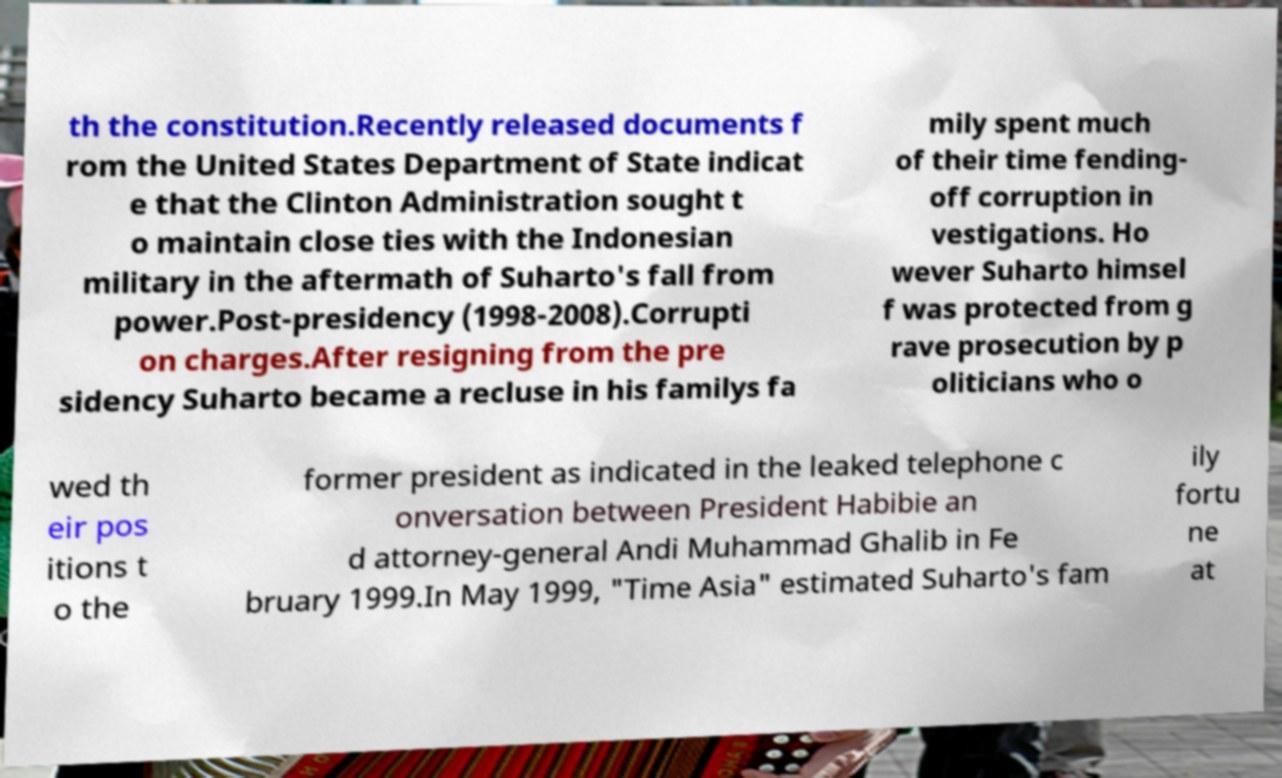Could you extract and type out the text from this image? th the constitution.Recently released documents f rom the United States Department of State indicat e that the Clinton Administration sought t o maintain close ties with the Indonesian military in the aftermath of Suharto's fall from power.Post-presidency (1998-2008).Corrupti on charges.After resigning from the pre sidency Suharto became a recluse in his familys fa mily spent much of their time fending- off corruption in vestigations. Ho wever Suharto himsel f was protected from g rave prosecution by p oliticians who o wed th eir pos itions t o the former president as indicated in the leaked telephone c onversation between President Habibie an d attorney-general Andi Muhammad Ghalib in Fe bruary 1999.In May 1999, "Time Asia" estimated Suharto's fam ily fortu ne at 